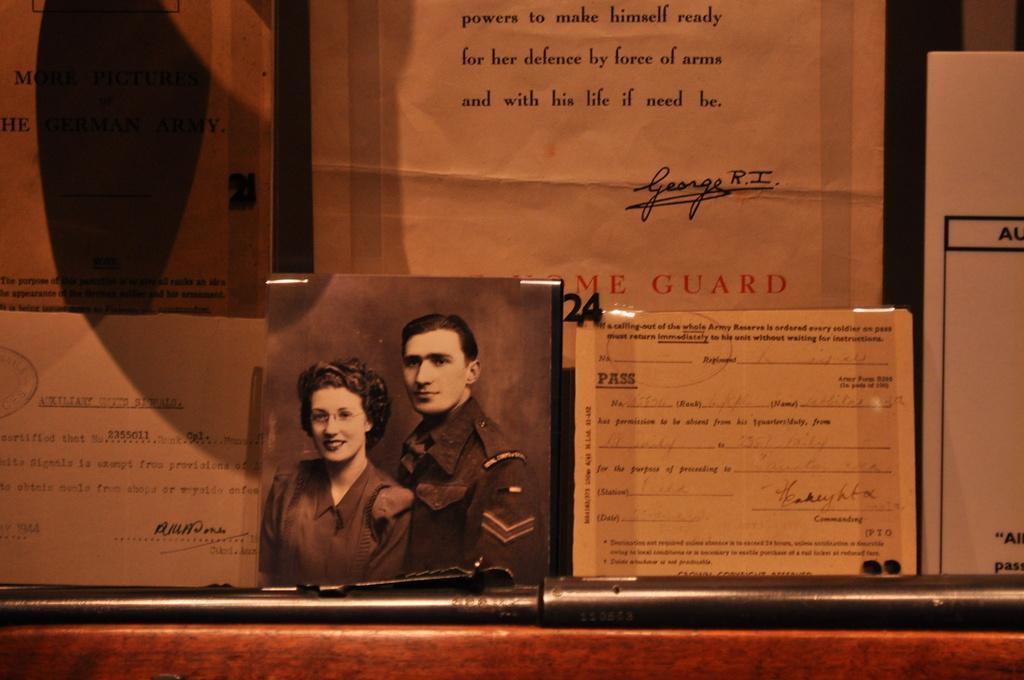Please provide a concise description of this image. In this image I can see few notice papers, in the notice papers I can see text and one woman and man 